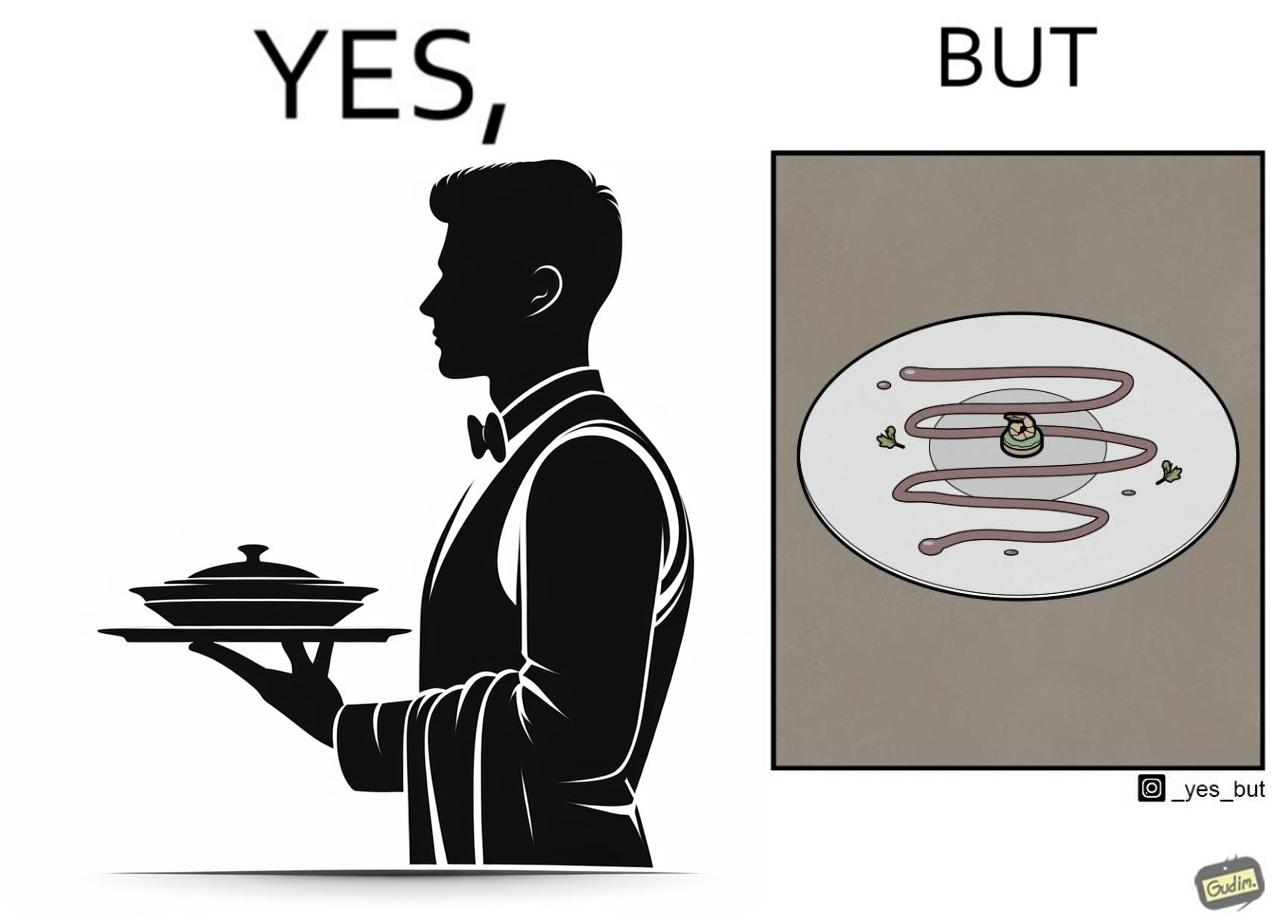Describe the contrast between the left and right parts of this image. In the left part of the image: a waiter bringing some dish with some stylish posture to the table In the right part of the image: a dish with only sauce or some cream with a very small piece to eat 